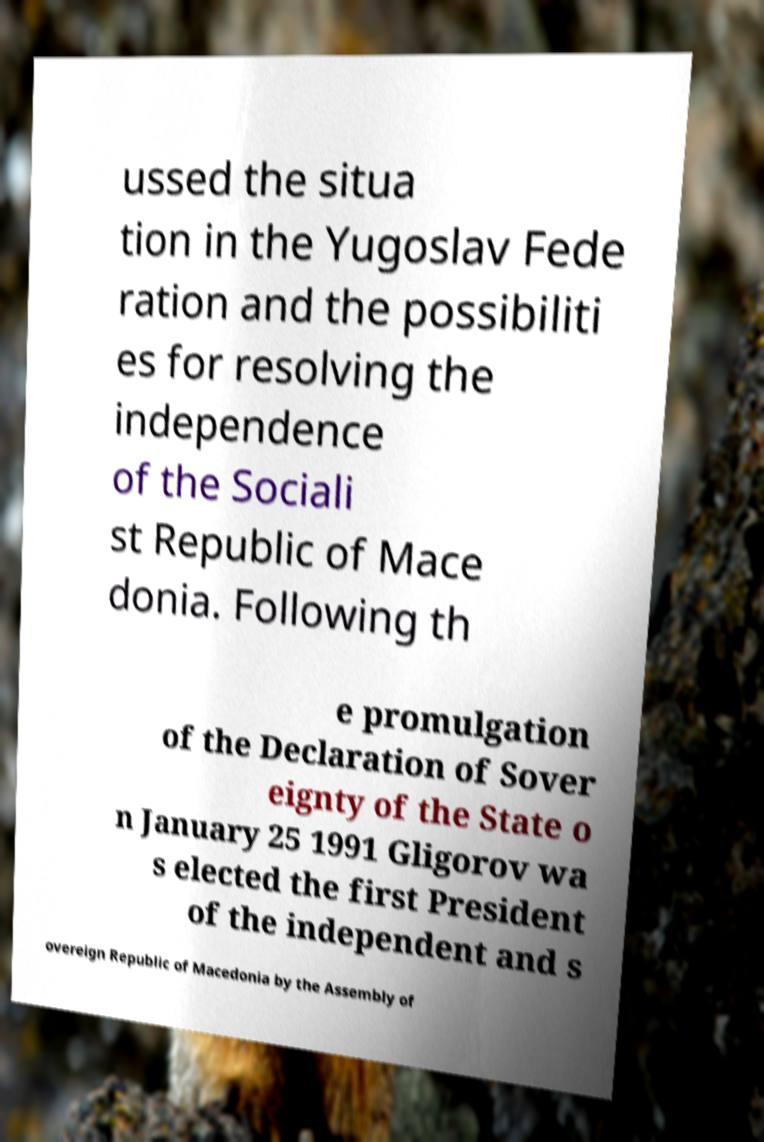Can you read and provide the text displayed in the image?This photo seems to have some interesting text. Can you extract and type it out for me? ussed the situa tion in the Yugoslav Fede ration and the possibiliti es for resolving the independence of the Sociali st Republic of Mace donia. Following th e promulgation of the Declaration of Sover eignty of the State o n January 25 1991 Gligorov wa s elected the first President of the independent and s overeign Republic of Macedonia by the Assembly of 